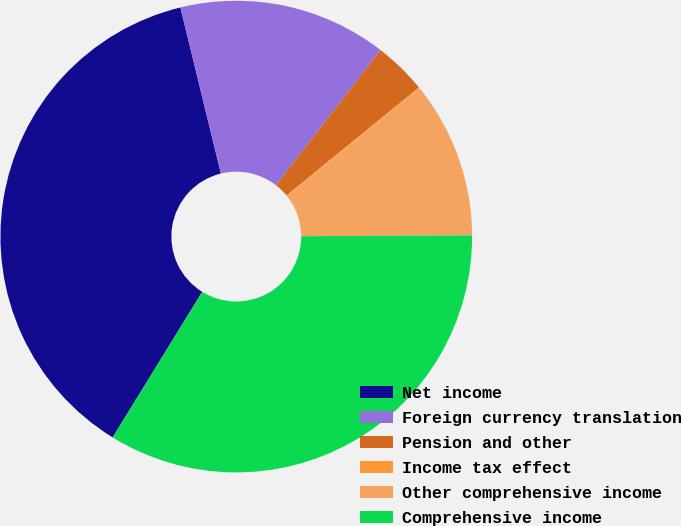Convert chart to OTSL. <chart><loc_0><loc_0><loc_500><loc_500><pie_chart><fcel>Net income<fcel>Foreign currency translation<fcel>Pension and other<fcel>Income tax effect<fcel>Other comprehensive income<fcel>Comprehensive income<nl><fcel>37.41%<fcel>14.28%<fcel>3.63%<fcel>0.08%<fcel>10.73%<fcel>33.86%<nl></chart> 